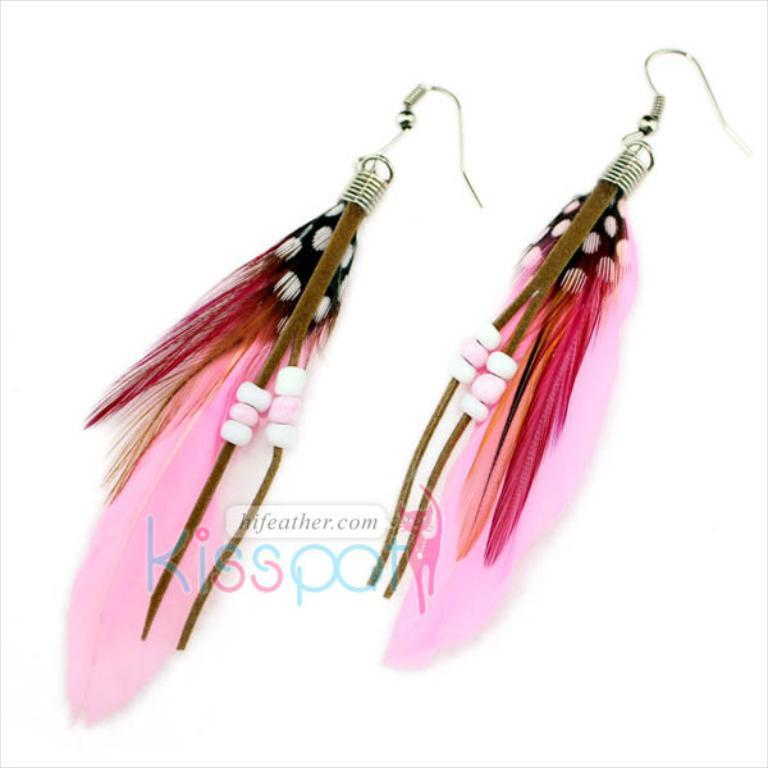What type of accessory is visible in the image? There are earrings in the image. What else can be seen in the middle of the image? There is text in the middle of the image. How many airplanes are flying in the image? There are no airplanes visible in the image. What type of farewell is being expressed in the image? The image does not depict any good-byes or farewells. 